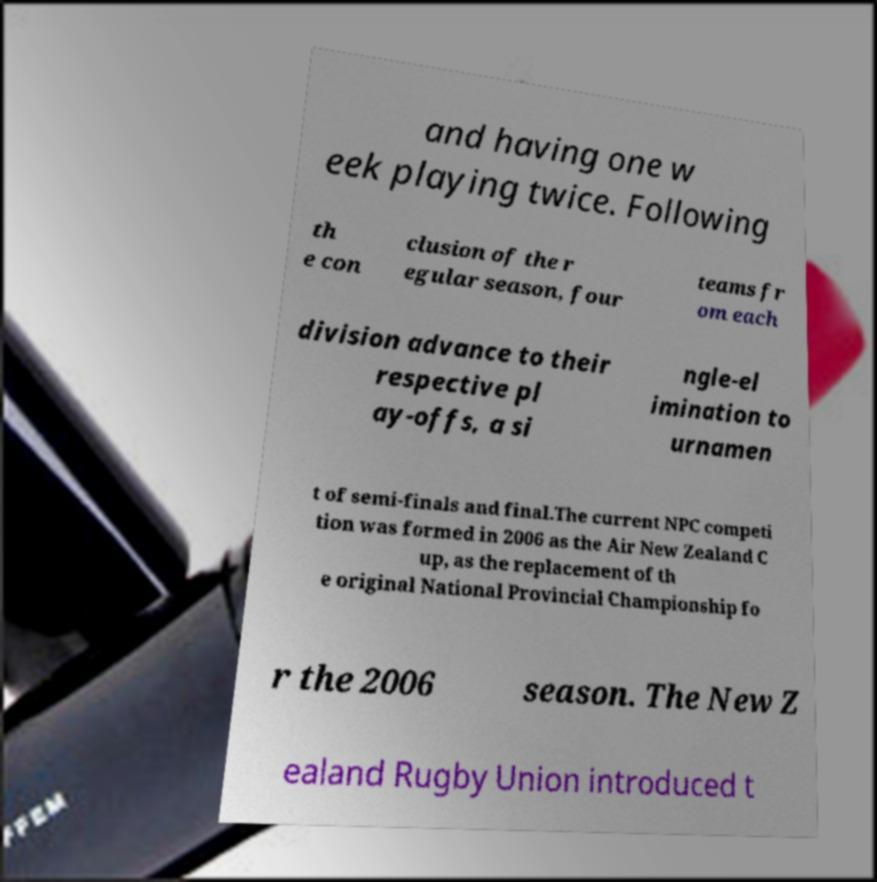Could you assist in decoding the text presented in this image and type it out clearly? and having one w eek playing twice. Following th e con clusion of the r egular season, four teams fr om each division advance to their respective pl ay-offs, a si ngle-el imination to urnamen t of semi-finals and final.The current NPC competi tion was formed in 2006 as the Air New Zealand C up, as the replacement of th e original National Provincial Championship fo r the 2006 season. The New Z ealand Rugby Union introduced t 